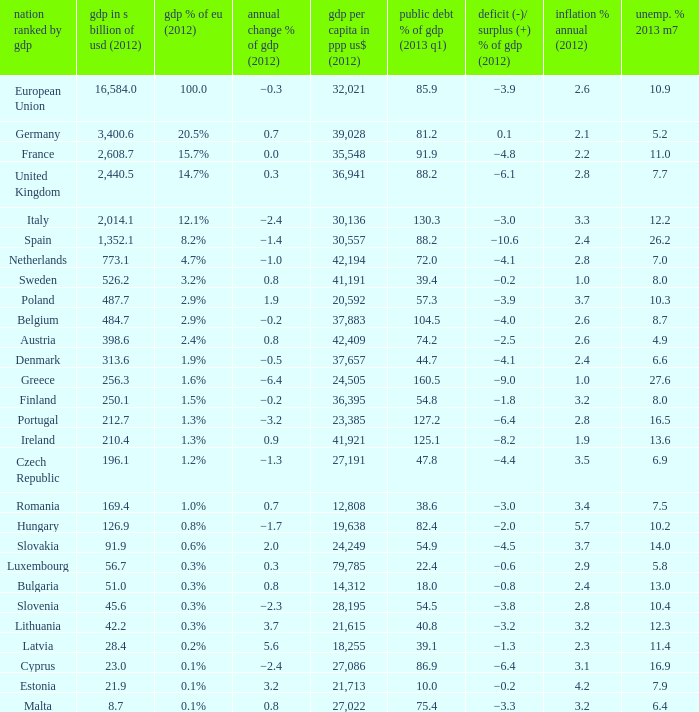What is the deficit/surplus % of the 2012 GDP of the country with a GDP in billions of USD in 2012 less than 1,352.1, a GDP per capita in PPP US dollars in 2012 greater than 21,615, public debt % of GDP in the 2013 Q1 less than 75.4, and an inflation % annual in 2012 of 2.9? −0.6. 